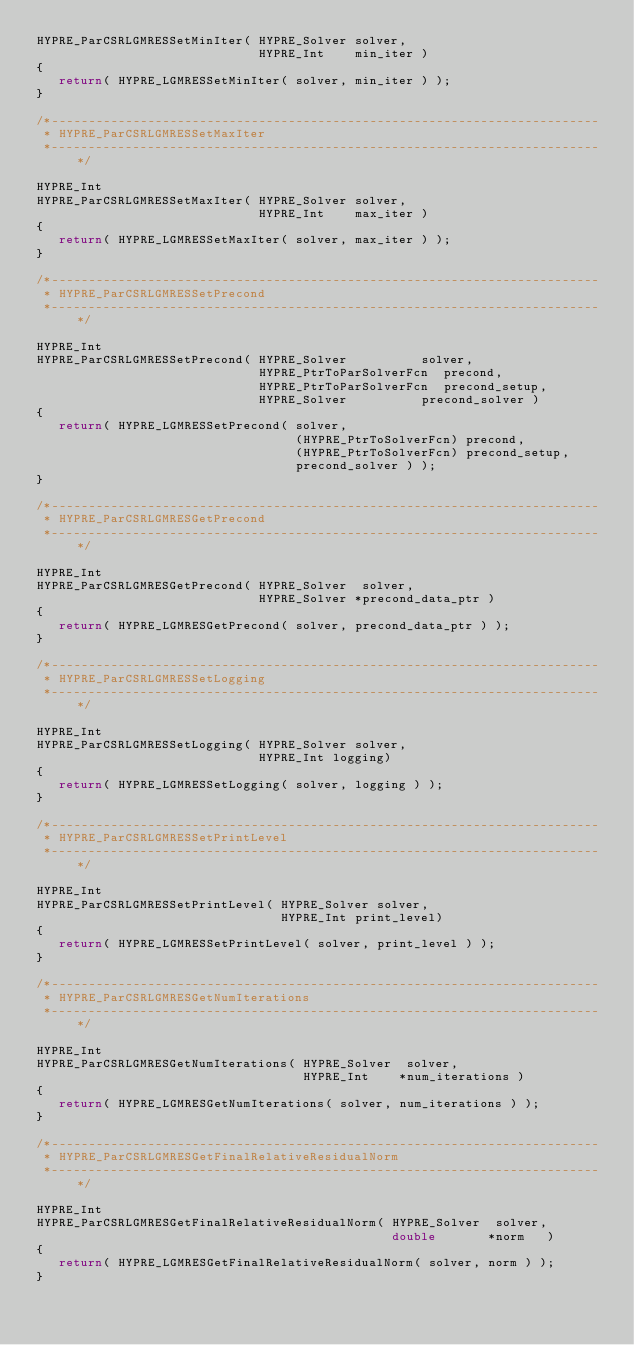<code> <loc_0><loc_0><loc_500><loc_500><_C_>HYPRE_ParCSRLGMRESSetMinIter( HYPRE_Solver solver,
                              HYPRE_Int    min_iter )
{
   return( HYPRE_LGMRESSetMinIter( solver, min_iter ) );
}

/*--------------------------------------------------------------------------
 * HYPRE_ParCSRLGMRESSetMaxIter
 *--------------------------------------------------------------------------*/

HYPRE_Int
HYPRE_ParCSRLGMRESSetMaxIter( HYPRE_Solver solver,
                              HYPRE_Int    max_iter )
{
   return( HYPRE_LGMRESSetMaxIter( solver, max_iter ) );
}

/*--------------------------------------------------------------------------
 * HYPRE_ParCSRLGMRESSetPrecond
 *--------------------------------------------------------------------------*/

HYPRE_Int
HYPRE_ParCSRLGMRESSetPrecond( HYPRE_Solver          solver,
                              HYPRE_PtrToParSolverFcn  precond,
                              HYPRE_PtrToParSolverFcn  precond_setup,
                              HYPRE_Solver          precond_solver )
{
   return( HYPRE_LGMRESSetPrecond( solver,
                                   (HYPRE_PtrToSolverFcn) precond,
                                   (HYPRE_PtrToSolverFcn) precond_setup,
                                   precond_solver ) );
}

/*--------------------------------------------------------------------------
 * HYPRE_ParCSRLGMRESGetPrecond
 *--------------------------------------------------------------------------*/

HYPRE_Int
HYPRE_ParCSRLGMRESGetPrecond( HYPRE_Solver  solver,
                              HYPRE_Solver *precond_data_ptr )
{
   return( HYPRE_LGMRESGetPrecond( solver, precond_data_ptr ) );
}

/*--------------------------------------------------------------------------
 * HYPRE_ParCSRLGMRESSetLogging
 *--------------------------------------------------------------------------*/

HYPRE_Int
HYPRE_ParCSRLGMRESSetLogging( HYPRE_Solver solver,
                              HYPRE_Int logging)
{
   return( HYPRE_LGMRESSetLogging( solver, logging ) );
}

/*--------------------------------------------------------------------------
 * HYPRE_ParCSRLGMRESSetPrintLevel
 *--------------------------------------------------------------------------*/

HYPRE_Int
HYPRE_ParCSRLGMRESSetPrintLevel( HYPRE_Solver solver,
                                 HYPRE_Int print_level)
{
   return( HYPRE_LGMRESSetPrintLevel( solver, print_level ) );
}

/*--------------------------------------------------------------------------
 * HYPRE_ParCSRLGMRESGetNumIterations
 *--------------------------------------------------------------------------*/

HYPRE_Int
HYPRE_ParCSRLGMRESGetNumIterations( HYPRE_Solver  solver,
                                    HYPRE_Int    *num_iterations )
{
   return( HYPRE_LGMRESGetNumIterations( solver, num_iterations ) );
}

/*--------------------------------------------------------------------------
 * HYPRE_ParCSRLGMRESGetFinalRelativeResidualNorm
 *--------------------------------------------------------------------------*/

HYPRE_Int
HYPRE_ParCSRLGMRESGetFinalRelativeResidualNorm( HYPRE_Solver  solver,
                                                double       *norm   )
{
   return( HYPRE_LGMRESGetFinalRelativeResidualNorm( solver, norm ) );
}
</code> 